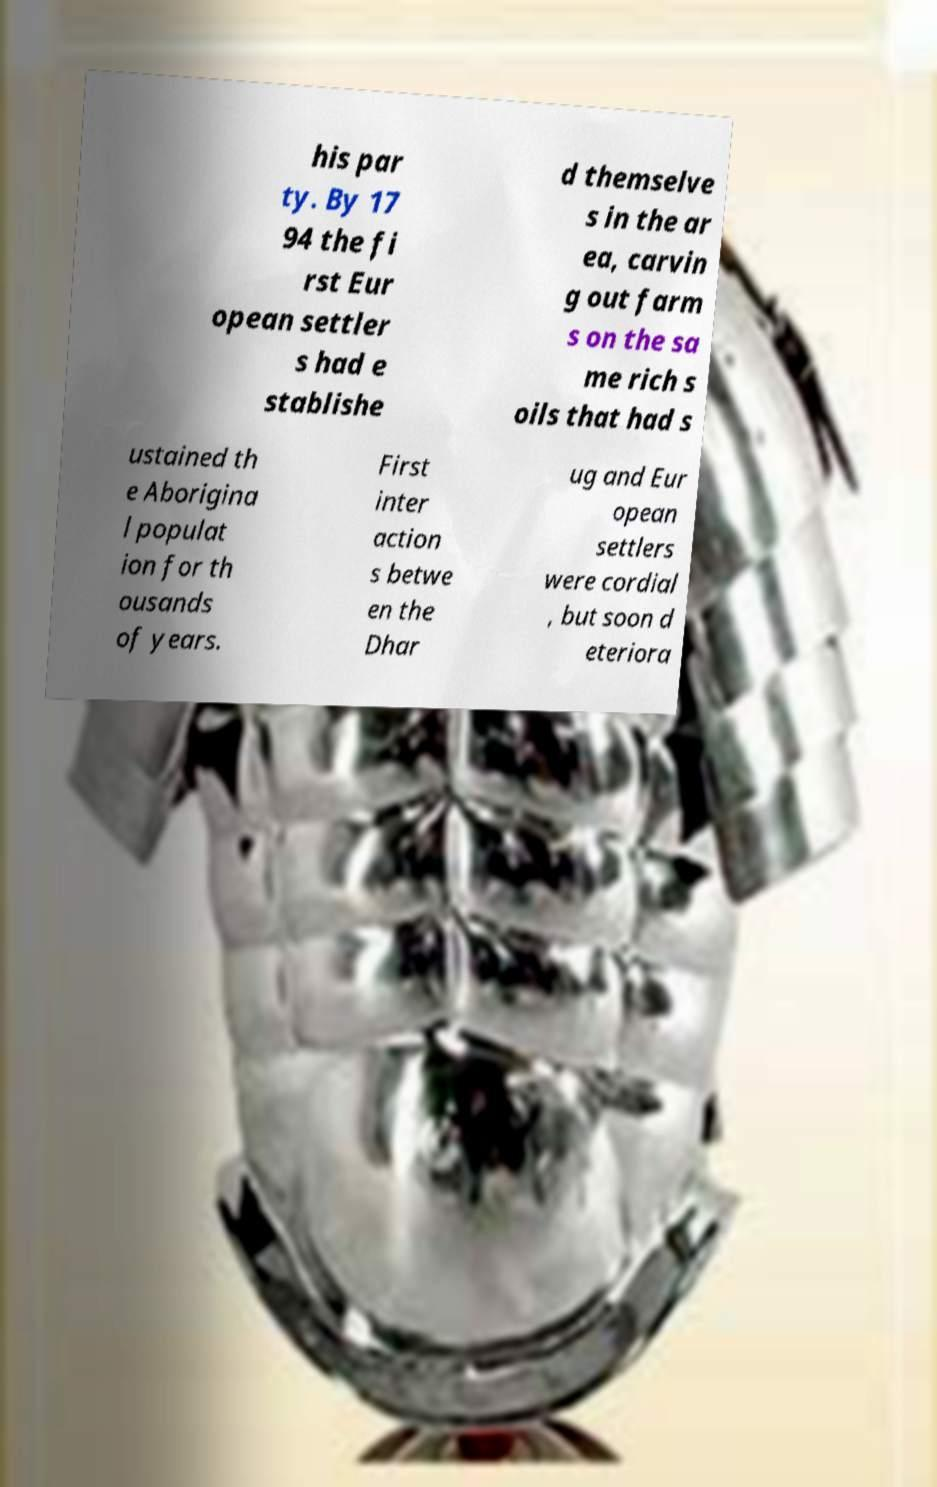There's text embedded in this image that I need extracted. Can you transcribe it verbatim? his par ty. By 17 94 the fi rst Eur opean settler s had e stablishe d themselve s in the ar ea, carvin g out farm s on the sa me rich s oils that had s ustained th e Aborigina l populat ion for th ousands of years. First inter action s betwe en the Dhar ug and Eur opean settlers were cordial , but soon d eteriora 